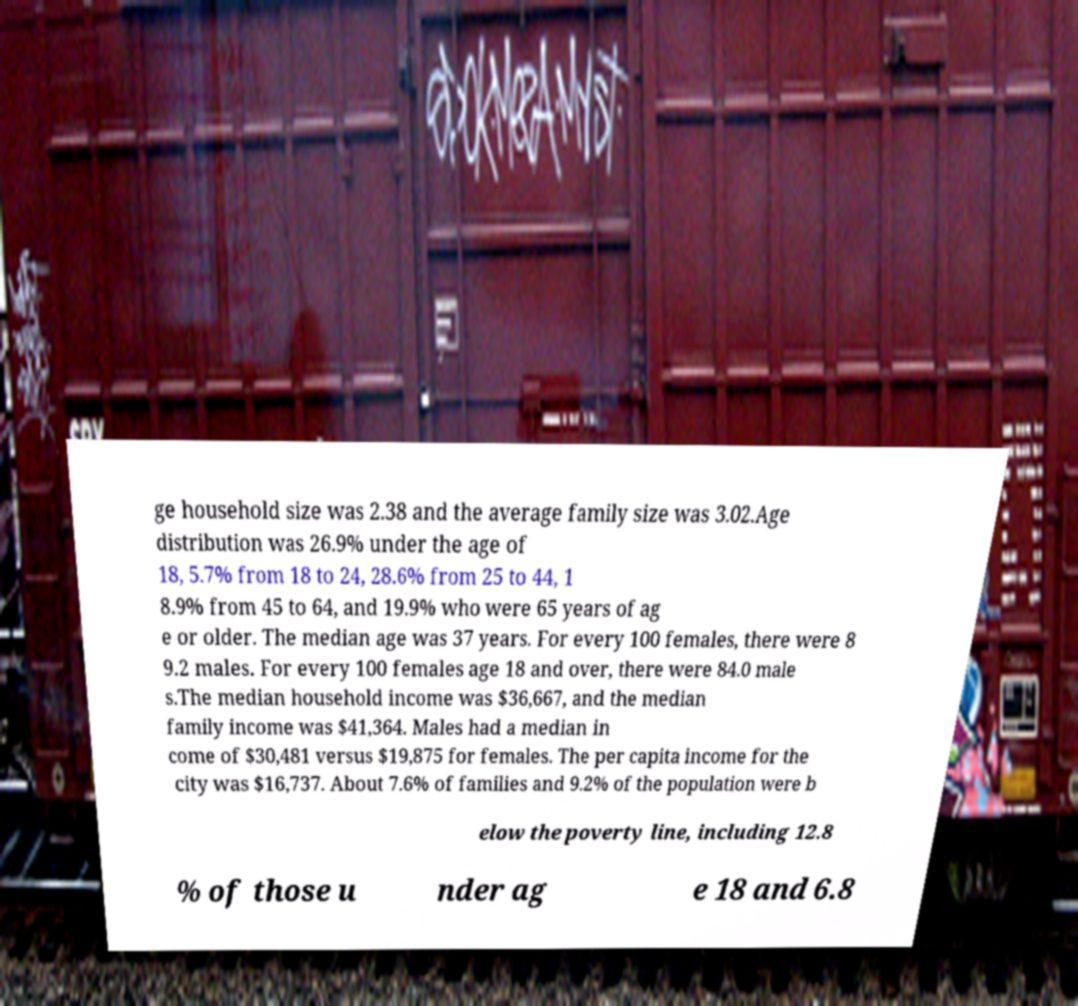Can you read and provide the text displayed in the image?This photo seems to have some interesting text. Can you extract and type it out for me? ge household size was 2.38 and the average family size was 3.02.Age distribution was 26.9% under the age of 18, 5.7% from 18 to 24, 28.6% from 25 to 44, 1 8.9% from 45 to 64, and 19.9% who were 65 years of ag e or older. The median age was 37 years. For every 100 females, there were 8 9.2 males. For every 100 females age 18 and over, there were 84.0 male s.The median household income was $36,667, and the median family income was $41,364. Males had a median in come of $30,481 versus $19,875 for females. The per capita income for the city was $16,737. About 7.6% of families and 9.2% of the population were b elow the poverty line, including 12.8 % of those u nder ag e 18 and 6.8 